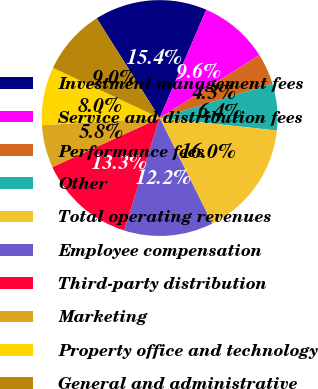Convert chart to OTSL. <chart><loc_0><loc_0><loc_500><loc_500><pie_chart><fcel>Investment management fees<fcel>Service and distribution fees<fcel>Performance fees<fcel>Other<fcel>Total operating revenues<fcel>Employee compensation<fcel>Third-party distribution<fcel>Marketing<fcel>Property office and technology<fcel>General and administrative<nl><fcel>15.43%<fcel>9.57%<fcel>4.26%<fcel>6.38%<fcel>15.96%<fcel>12.23%<fcel>13.3%<fcel>5.85%<fcel>7.98%<fcel>9.04%<nl></chart> 